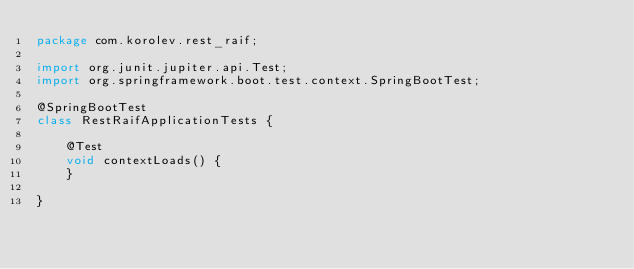<code> <loc_0><loc_0><loc_500><loc_500><_Java_>package com.korolev.rest_raif;

import org.junit.jupiter.api.Test;
import org.springframework.boot.test.context.SpringBootTest;

@SpringBootTest
class RestRaifApplicationTests {

	@Test
	void contextLoads() {
	}

}
</code> 